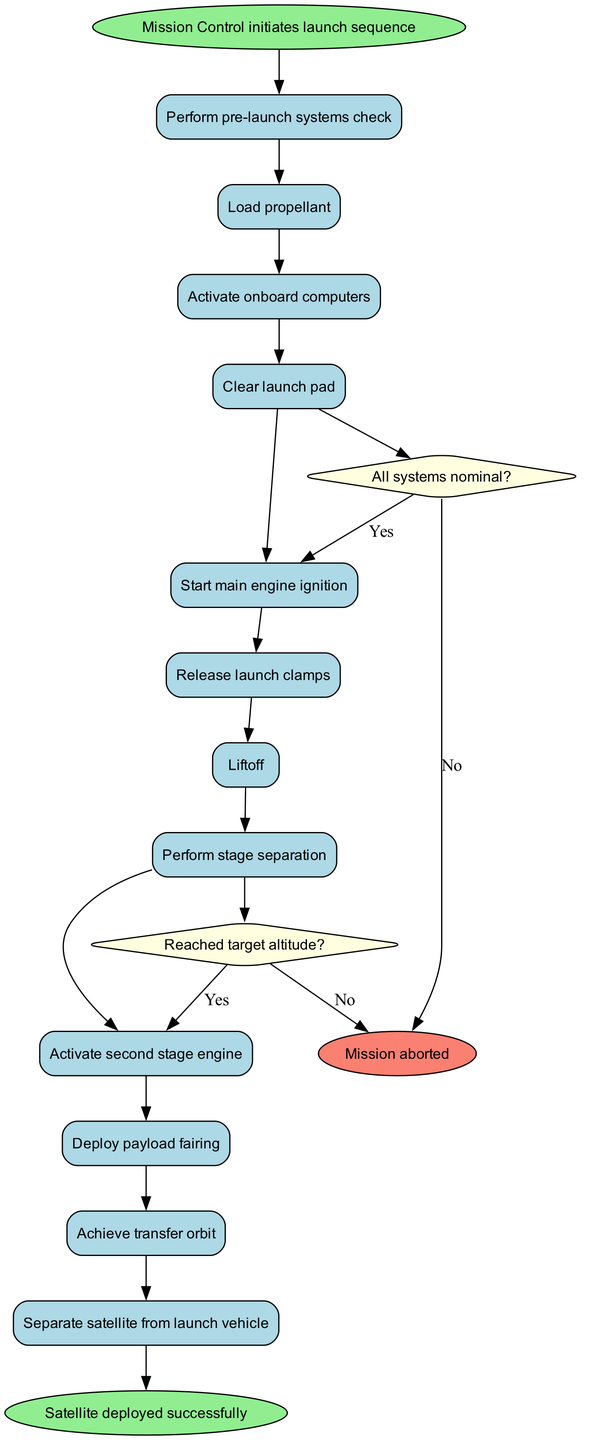What is the starting point of the launch sequence? The starting point is the node labeled "Mission Control initiates launch sequence." This is clearly indicated as the first action in the diagram.
Answer: Mission Control initiates launch sequence How many activities are listed in the diagram? The diagram includes a total of 12 activities. Each activity is represented as a separate node, and counting them reveals the total.
Answer: 12 What is the condition checked after the engines are ignited? The decision node represents the condition "All systems nominal?" which is checked after the step "Start main engine ignition." It determines if the launch can continue or if an abort is necessary.
Answer: All systems nominal? What happens if "All systems nominal?" is answered with "No"? In this case, the diagram shows that the result would be to "Abort launch." Thus, a negative response to this decision leads to the aborting of the mission.
Answer: Abort launch What is the final outcome if the launch sequence proceeds without issues? If the launch sequence continues without abnormalities, the final outcome illustrated in the diagram is "Satellite deployed successfully," indicating the mission's success.
Answer: Satellite deployed successfully Which activity occurs right before the deployment of the payload fairing? The activity that precedes the "Deploy payload fairing" is "Activate second stage engine." This order is clear through the sequential flow of actions in the diagram.
Answer: Activate second stage engine What is the next step if the condition "Reached target altitude?" is answered with "Yes"? If "Reached target altitude?" is evaluated and answered with "Yes," the diagram specifies that the next step is "Proceed to orbit insertion," indicating advancement in the launch process.
Answer: Proceed to orbit insertion How many decision points are in the activity diagram? The diagram contains two decision points, represented by diamond nodes, each evaluating specific conditions related to the launch sequence.
Answer: 2 What action directly follows the "Liftoff" activity in the sequence? The next action after "Liftoff" in the sequence is "Perform stage separation." This can be traced through the flow connecting these two activities in the diagram.
Answer: Perform stage separation 